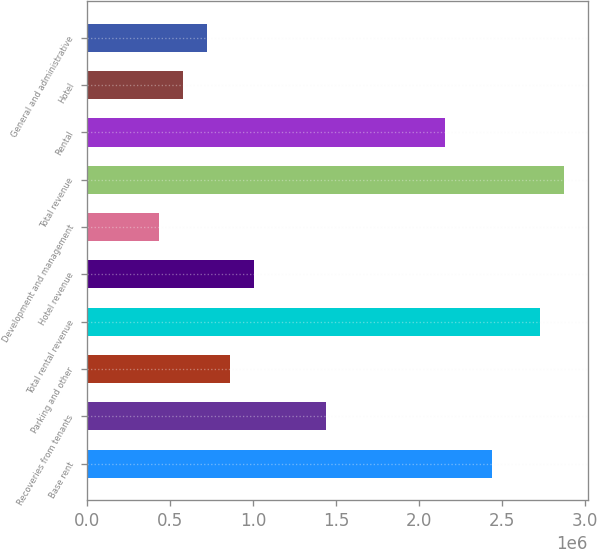<chart> <loc_0><loc_0><loc_500><loc_500><bar_chart><fcel>Base rent<fcel>Recoveries from tenants<fcel>Parking and other<fcel>Total rental revenue<fcel>Hotel revenue<fcel>Development and management<fcel>Total revenue<fcel>Rental<fcel>Hotel<fcel>General and administrative<nl><fcel>2.44398e+06<fcel>1.43764e+06<fcel>862582<fcel>2.7315e+06<fcel>1.00635e+06<fcel>431293<fcel>2.87527e+06<fcel>2.15645e+06<fcel>575056<fcel>718819<nl></chart> 